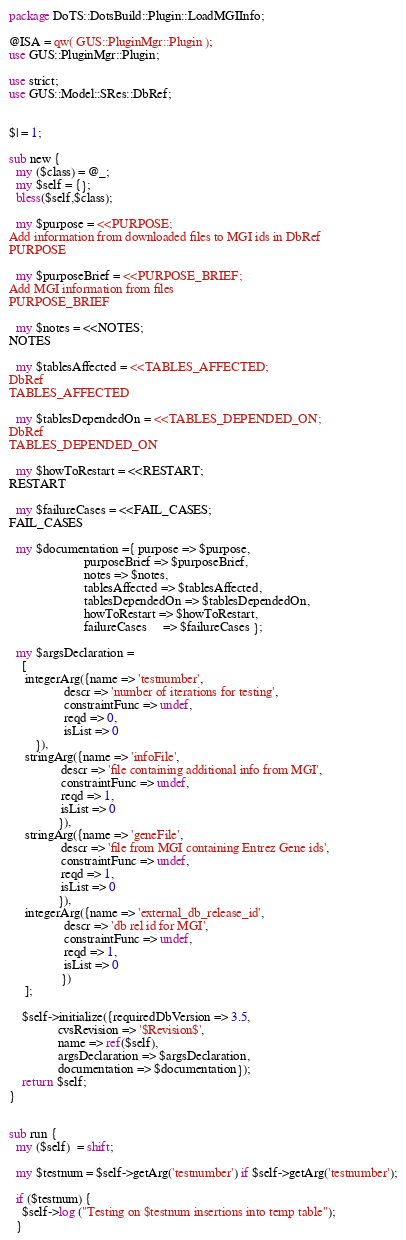<code> <loc_0><loc_0><loc_500><loc_500><_Perl_>package DoTS::DotsBuild::Plugin::LoadMGIInfo;

@ISA = qw( GUS::PluginMgr::Plugin );
use GUS::PluginMgr::Plugin;

use strict;
use GUS::Model::SRes::DbRef;


$| = 1;

sub new {
  my ($class) = @_;
  my $self = {};
  bless($self,$class);

  my $purpose = <<PURPOSE;
Add information from downloaded files to MGI ids in DbRef
PURPOSE

  my $purposeBrief = <<PURPOSE_BRIEF;
Add MGI information from files
PURPOSE_BRIEF

  my $notes = <<NOTES;
NOTES

  my $tablesAffected = <<TABLES_AFFECTED;
DbRef
TABLES_AFFECTED

  my $tablesDependedOn = <<TABLES_DEPENDED_ON;
DbRef
TABLES_DEPENDED_ON

  my $howToRestart = <<RESTART;
RESTART

  my $failureCases = <<FAIL_CASES;
FAIL_CASES

  my $documentation ={ purpose => $purpose,
                       purposeBrief => $purposeBrief,
                       notes => $notes,
                       tablesAffected => $tablesAffected,
                       tablesDependedOn => $tablesDependedOn,
                       howToRestart => $howToRestart,
                       failureCases     => $failureCases };

  my $argsDeclaration =
    [
     integerArg({name => 'testnumber',
                 descr => 'number of iterations for testing',
                 constraintFunc => undef,
                 reqd => 0,
                 isList => 0
		}),
     stringArg({name => 'infoFile',
                descr => 'file containing additional info from MGI',
                constraintFunc => undef,
                reqd => 1,
                isList => 0
               }),
     stringArg({name => 'geneFile',
                descr => 'file from MGI containing Entrez Gene ids',
                constraintFunc => undef,
                reqd => 1,
                isList => 0
               }),
     integerArg({name => 'external_db_release_id',
                 descr => 'db rel id for MGI',
                 constraintFunc => undef,
                 reqd => 1,
                 isList => 0
                })
	 ];

    $self->initialize({requiredDbVersion => 3.5,
		       cvsRevision => '$Revision$',
		       name => ref($self),
		       argsDeclaration => $argsDeclaration,
		       documentation => $documentation});
    return $self;
}


sub run {
  my ($self)  = shift;

  my $testnum = $self->getArg('testnumber') if $self->getArg('testnumber');

  if ($testnum) {
    $self->log ("Testing on $testnum insertions into temp table");
  }
</code> 